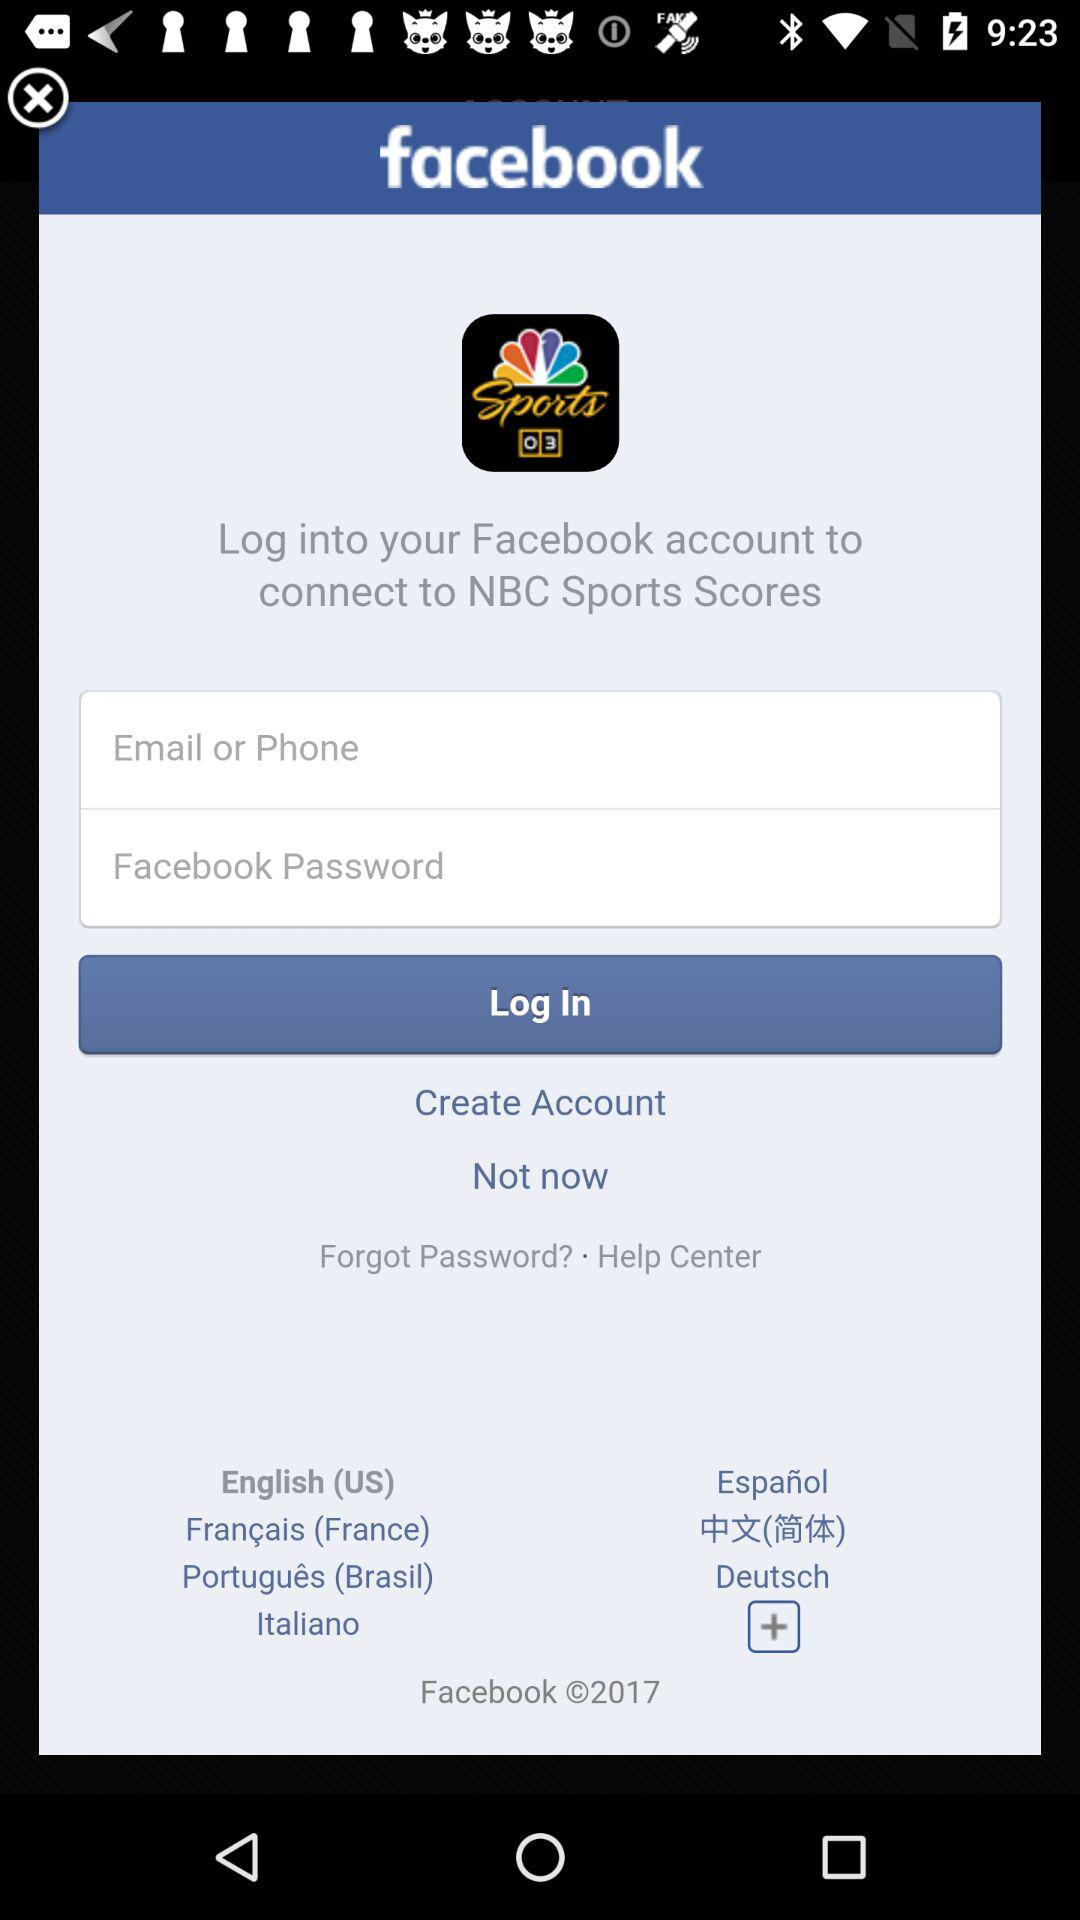How many languages are available for the user to choose from?
Answer the question using a single word or phrase. 7 